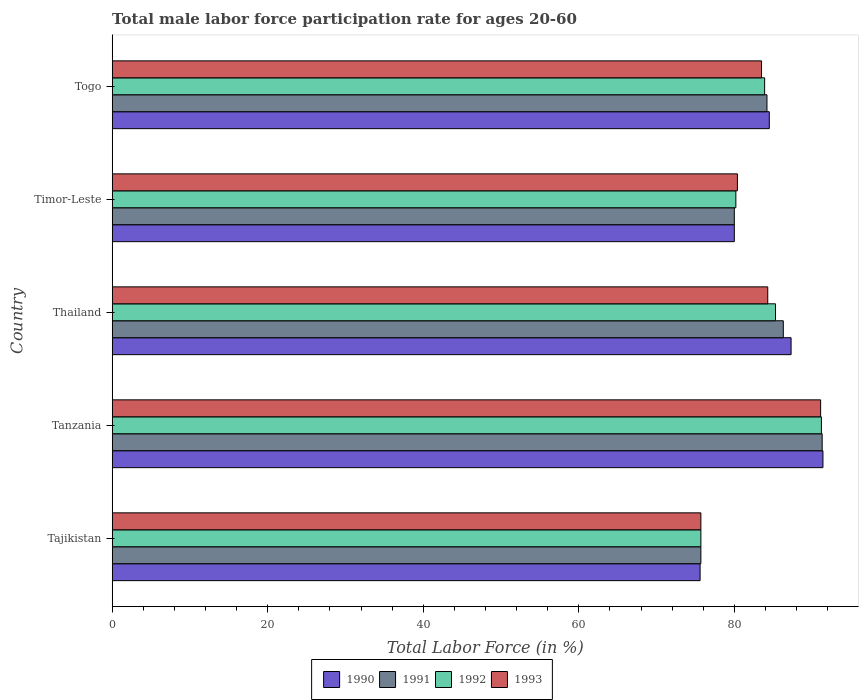How many different coloured bars are there?
Keep it short and to the point. 4. How many bars are there on the 3rd tick from the top?
Your answer should be compact. 4. What is the label of the 3rd group of bars from the top?
Your answer should be very brief. Thailand. In how many cases, is the number of bars for a given country not equal to the number of legend labels?
Offer a very short reply. 0. What is the male labor force participation rate in 1992 in Tajikistan?
Offer a terse response. 75.7. Across all countries, what is the maximum male labor force participation rate in 1993?
Ensure brevity in your answer.  91.1. Across all countries, what is the minimum male labor force participation rate in 1993?
Offer a very short reply. 75.7. In which country was the male labor force participation rate in 1990 maximum?
Make the answer very short. Tanzania. In which country was the male labor force participation rate in 1990 minimum?
Your answer should be very brief. Tajikistan. What is the total male labor force participation rate in 1990 in the graph?
Offer a terse response. 418.8. What is the difference between the male labor force participation rate in 1992 in Thailand and that in Togo?
Your answer should be very brief. 1.4. What is the difference between the male labor force participation rate in 1990 in Timor-Leste and the male labor force participation rate in 1992 in Tajikistan?
Provide a short and direct response. 4.3. What is the average male labor force participation rate in 1992 per country?
Make the answer very short. 83.26. In how many countries, is the male labor force participation rate in 1991 greater than 8 %?
Offer a terse response. 5. What is the ratio of the male labor force participation rate in 1991 in Tanzania to that in Thailand?
Provide a succinct answer. 1.06. Is the male labor force participation rate in 1990 in Tanzania less than that in Thailand?
Provide a succinct answer. No. Is the difference between the male labor force participation rate in 1991 in Tajikistan and Thailand greater than the difference between the male labor force participation rate in 1993 in Tajikistan and Thailand?
Your response must be concise. No. What is the difference between the highest and the second highest male labor force participation rate in 1991?
Your response must be concise. 5. What is the difference between the highest and the lowest male labor force participation rate in 1990?
Offer a very short reply. 15.8. Is the sum of the male labor force participation rate in 1992 in Tajikistan and Thailand greater than the maximum male labor force participation rate in 1993 across all countries?
Ensure brevity in your answer.  Yes. What does the 3rd bar from the top in Tajikistan represents?
Keep it short and to the point. 1991. What does the 3rd bar from the bottom in Tanzania represents?
Provide a succinct answer. 1992. Is it the case that in every country, the sum of the male labor force participation rate in 1993 and male labor force participation rate in 1990 is greater than the male labor force participation rate in 1992?
Provide a succinct answer. Yes. Are all the bars in the graph horizontal?
Keep it short and to the point. Yes. How many countries are there in the graph?
Provide a short and direct response. 5. Are the values on the major ticks of X-axis written in scientific E-notation?
Provide a short and direct response. No. Does the graph contain any zero values?
Ensure brevity in your answer.  No. Where does the legend appear in the graph?
Ensure brevity in your answer.  Bottom center. What is the title of the graph?
Your answer should be very brief. Total male labor force participation rate for ages 20-60. What is the Total Labor Force (in %) of 1990 in Tajikistan?
Provide a short and direct response. 75.6. What is the Total Labor Force (in %) of 1991 in Tajikistan?
Ensure brevity in your answer.  75.7. What is the Total Labor Force (in %) in 1992 in Tajikistan?
Make the answer very short. 75.7. What is the Total Labor Force (in %) of 1993 in Tajikistan?
Offer a very short reply. 75.7. What is the Total Labor Force (in %) in 1990 in Tanzania?
Make the answer very short. 91.4. What is the Total Labor Force (in %) in 1991 in Tanzania?
Provide a short and direct response. 91.3. What is the Total Labor Force (in %) in 1992 in Tanzania?
Your answer should be very brief. 91.2. What is the Total Labor Force (in %) in 1993 in Tanzania?
Provide a short and direct response. 91.1. What is the Total Labor Force (in %) of 1990 in Thailand?
Offer a very short reply. 87.3. What is the Total Labor Force (in %) in 1991 in Thailand?
Offer a very short reply. 86.3. What is the Total Labor Force (in %) of 1992 in Thailand?
Your answer should be compact. 85.3. What is the Total Labor Force (in %) in 1993 in Thailand?
Provide a short and direct response. 84.3. What is the Total Labor Force (in %) in 1990 in Timor-Leste?
Make the answer very short. 80. What is the Total Labor Force (in %) in 1992 in Timor-Leste?
Ensure brevity in your answer.  80.2. What is the Total Labor Force (in %) of 1993 in Timor-Leste?
Make the answer very short. 80.4. What is the Total Labor Force (in %) of 1990 in Togo?
Your answer should be very brief. 84.5. What is the Total Labor Force (in %) in 1991 in Togo?
Keep it short and to the point. 84.2. What is the Total Labor Force (in %) of 1992 in Togo?
Provide a succinct answer. 83.9. What is the Total Labor Force (in %) of 1993 in Togo?
Ensure brevity in your answer.  83.5. Across all countries, what is the maximum Total Labor Force (in %) of 1990?
Keep it short and to the point. 91.4. Across all countries, what is the maximum Total Labor Force (in %) of 1991?
Give a very brief answer. 91.3. Across all countries, what is the maximum Total Labor Force (in %) of 1992?
Your response must be concise. 91.2. Across all countries, what is the maximum Total Labor Force (in %) in 1993?
Your answer should be compact. 91.1. Across all countries, what is the minimum Total Labor Force (in %) in 1990?
Provide a succinct answer. 75.6. Across all countries, what is the minimum Total Labor Force (in %) in 1991?
Give a very brief answer. 75.7. Across all countries, what is the minimum Total Labor Force (in %) in 1992?
Make the answer very short. 75.7. Across all countries, what is the minimum Total Labor Force (in %) of 1993?
Offer a very short reply. 75.7. What is the total Total Labor Force (in %) in 1990 in the graph?
Provide a short and direct response. 418.8. What is the total Total Labor Force (in %) of 1991 in the graph?
Your answer should be compact. 417.5. What is the total Total Labor Force (in %) of 1992 in the graph?
Your answer should be very brief. 416.3. What is the total Total Labor Force (in %) of 1993 in the graph?
Provide a succinct answer. 415. What is the difference between the Total Labor Force (in %) of 1990 in Tajikistan and that in Tanzania?
Give a very brief answer. -15.8. What is the difference between the Total Labor Force (in %) of 1991 in Tajikistan and that in Tanzania?
Provide a succinct answer. -15.6. What is the difference between the Total Labor Force (in %) of 1992 in Tajikistan and that in Tanzania?
Provide a short and direct response. -15.5. What is the difference between the Total Labor Force (in %) in 1993 in Tajikistan and that in Tanzania?
Your answer should be very brief. -15.4. What is the difference between the Total Labor Force (in %) of 1990 in Tajikistan and that in Thailand?
Provide a short and direct response. -11.7. What is the difference between the Total Labor Force (in %) in 1993 in Tajikistan and that in Thailand?
Your answer should be compact. -8.6. What is the difference between the Total Labor Force (in %) of 1992 in Tajikistan and that in Togo?
Provide a succinct answer. -8.2. What is the difference between the Total Labor Force (in %) in 1993 in Tajikistan and that in Togo?
Offer a terse response. -7.8. What is the difference between the Total Labor Force (in %) in 1990 in Tanzania and that in Thailand?
Your answer should be very brief. 4.1. What is the difference between the Total Labor Force (in %) of 1991 in Tanzania and that in Thailand?
Give a very brief answer. 5. What is the difference between the Total Labor Force (in %) of 1993 in Tanzania and that in Thailand?
Your answer should be very brief. 6.8. What is the difference between the Total Labor Force (in %) in 1990 in Tanzania and that in Timor-Leste?
Your response must be concise. 11.4. What is the difference between the Total Labor Force (in %) in 1992 in Tanzania and that in Timor-Leste?
Provide a short and direct response. 11. What is the difference between the Total Labor Force (in %) of 1993 in Tanzania and that in Timor-Leste?
Make the answer very short. 10.7. What is the difference between the Total Labor Force (in %) of 1990 in Tanzania and that in Togo?
Keep it short and to the point. 6.9. What is the difference between the Total Labor Force (in %) in 1992 in Tanzania and that in Togo?
Give a very brief answer. 7.3. What is the difference between the Total Labor Force (in %) of 1990 in Thailand and that in Timor-Leste?
Provide a short and direct response. 7.3. What is the difference between the Total Labor Force (in %) of 1992 in Thailand and that in Timor-Leste?
Provide a short and direct response. 5.1. What is the difference between the Total Labor Force (in %) of 1993 in Thailand and that in Timor-Leste?
Ensure brevity in your answer.  3.9. What is the difference between the Total Labor Force (in %) in 1990 in Thailand and that in Togo?
Ensure brevity in your answer.  2.8. What is the difference between the Total Labor Force (in %) in 1992 in Thailand and that in Togo?
Offer a very short reply. 1.4. What is the difference between the Total Labor Force (in %) of 1993 in Thailand and that in Togo?
Provide a short and direct response. 0.8. What is the difference between the Total Labor Force (in %) of 1990 in Timor-Leste and that in Togo?
Ensure brevity in your answer.  -4.5. What is the difference between the Total Labor Force (in %) of 1991 in Timor-Leste and that in Togo?
Your response must be concise. -4.2. What is the difference between the Total Labor Force (in %) in 1993 in Timor-Leste and that in Togo?
Provide a short and direct response. -3.1. What is the difference between the Total Labor Force (in %) of 1990 in Tajikistan and the Total Labor Force (in %) of 1991 in Tanzania?
Give a very brief answer. -15.7. What is the difference between the Total Labor Force (in %) of 1990 in Tajikistan and the Total Labor Force (in %) of 1992 in Tanzania?
Keep it short and to the point. -15.6. What is the difference between the Total Labor Force (in %) of 1990 in Tajikistan and the Total Labor Force (in %) of 1993 in Tanzania?
Offer a very short reply. -15.5. What is the difference between the Total Labor Force (in %) in 1991 in Tajikistan and the Total Labor Force (in %) in 1992 in Tanzania?
Your response must be concise. -15.5. What is the difference between the Total Labor Force (in %) in 1991 in Tajikistan and the Total Labor Force (in %) in 1993 in Tanzania?
Provide a short and direct response. -15.4. What is the difference between the Total Labor Force (in %) of 1992 in Tajikistan and the Total Labor Force (in %) of 1993 in Tanzania?
Provide a short and direct response. -15.4. What is the difference between the Total Labor Force (in %) in 1990 in Tajikistan and the Total Labor Force (in %) in 1991 in Thailand?
Offer a terse response. -10.7. What is the difference between the Total Labor Force (in %) of 1990 in Tajikistan and the Total Labor Force (in %) of 1992 in Thailand?
Make the answer very short. -9.7. What is the difference between the Total Labor Force (in %) of 1992 in Tajikistan and the Total Labor Force (in %) of 1993 in Thailand?
Keep it short and to the point. -8.6. What is the difference between the Total Labor Force (in %) of 1990 in Tajikistan and the Total Labor Force (in %) of 1992 in Timor-Leste?
Offer a terse response. -4.6. What is the difference between the Total Labor Force (in %) of 1990 in Tajikistan and the Total Labor Force (in %) of 1993 in Timor-Leste?
Offer a terse response. -4.8. What is the difference between the Total Labor Force (in %) in 1991 in Tajikistan and the Total Labor Force (in %) in 1992 in Timor-Leste?
Provide a short and direct response. -4.5. What is the difference between the Total Labor Force (in %) of 1990 in Tajikistan and the Total Labor Force (in %) of 1991 in Togo?
Your answer should be very brief. -8.6. What is the difference between the Total Labor Force (in %) of 1990 in Tajikistan and the Total Labor Force (in %) of 1992 in Togo?
Offer a very short reply. -8.3. What is the difference between the Total Labor Force (in %) in 1990 in Tajikistan and the Total Labor Force (in %) in 1993 in Togo?
Your answer should be compact. -7.9. What is the difference between the Total Labor Force (in %) in 1991 in Tajikistan and the Total Labor Force (in %) in 1992 in Togo?
Offer a terse response. -8.2. What is the difference between the Total Labor Force (in %) in 1992 in Tajikistan and the Total Labor Force (in %) in 1993 in Togo?
Your response must be concise. -7.8. What is the difference between the Total Labor Force (in %) in 1990 in Tanzania and the Total Labor Force (in %) in 1992 in Thailand?
Offer a terse response. 6.1. What is the difference between the Total Labor Force (in %) in 1990 in Tanzania and the Total Labor Force (in %) in 1993 in Thailand?
Your response must be concise. 7.1. What is the difference between the Total Labor Force (in %) of 1991 in Tanzania and the Total Labor Force (in %) of 1992 in Thailand?
Offer a very short reply. 6. What is the difference between the Total Labor Force (in %) of 1991 in Tanzania and the Total Labor Force (in %) of 1993 in Thailand?
Your answer should be compact. 7. What is the difference between the Total Labor Force (in %) in 1990 in Tanzania and the Total Labor Force (in %) in 1991 in Timor-Leste?
Make the answer very short. 11.4. What is the difference between the Total Labor Force (in %) of 1990 in Tanzania and the Total Labor Force (in %) of 1993 in Timor-Leste?
Keep it short and to the point. 11. What is the difference between the Total Labor Force (in %) in 1991 in Tanzania and the Total Labor Force (in %) in 1992 in Timor-Leste?
Offer a terse response. 11.1. What is the difference between the Total Labor Force (in %) in 1991 in Tanzania and the Total Labor Force (in %) in 1993 in Timor-Leste?
Keep it short and to the point. 10.9. What is the difference between the Total Labor Force (in %) in 1990 in Tanzania and the Total Labor Force (in %) in 1992 in Togo?
Provide a short and direct response. 7.5. What is the difference between the Total Labor Force (in %) of 1991 in Tanzania and the Total Labor Force (in %) of 1993 in Togo?
Your answer should be very brief. 7.8. What is the difference between the Total Labor Force (in %) in 1990 in Thailand and the Total Labor Force (in %) in 1992 in Timor-Leste?
Make the answer very short. 7.1. What is the difference between the Total Labor Force (in %) of 1992 in Thailand and the Total Labor Force (in %) of 1993 in Timor-Leste?
Ensure brevity in your answer.  4.9. What is the difference between the Total Labor Force (in %) in 1990 in Thailand and the Total Labor Force (in %) in 1991 in Togo?
Ensure brevity in your answer.  3.1. What is the difference between the Total Labor Force (in %) in 1990 in Thailand and the Total Labor Force (in %) in 1993 in Togo?
Provide a short and direct response. 3.8. What is the difference between the Total Labor Force (in %) in 1991 in Thailand and the Total Labor Force (in %) in 1992 in Togo?
Keep it short and to the point. 2.4. What is the difference between the Total Labor Force (in %) in 1991 in Thailand and the Total Labor Force (in %) in 1993 in Togo?
Your answer should be very brief. 2.8. What is the difference between the Total Labor Force (in %) of 1990 in Timor-Leste and the Total Labor Force (in %) of 1992 in Togo?
Your response must be concise. -3.9. What is the difference between the Total Labor Force (in %) in 1990 in Timor-Leste and the Total Labor Force (in %) in 1993 in Togo?
Make the answer very short. -3.5. What is the difference between the Total Labor Force (in %) in 1991 in Timor-Leste and the Total Labor Force (in %) in 1993 in Togo?
Make the answer very short. -3.5. What is the difference between the Total Labor Force (in %) of 1992 in Timor-Leste and the Total Labor Force (in %) of 1993 in Togo?
Your answer should be very brief. -3.3. What is the average Total Labor Force (in %) in 1990 per country?
Provide a succinct answer. 83.76. What is the average Total Labor Force (in %) in 1991 per country?
Your response must be concise. 83.5. What is the average Total Labor Force (in %) in 1992 per country?
Ensure brevity in your answer.  83.26. What is the average Total Labor Force (in %) of 1993 per country?
Offer a very short reply. 83. What is the difference between the Total Labor Force (in %) in 1990 and Total Labor Force (in %) in 1991 in Tajikistan?
Your answer should be compact. -0.1. What is the difference between the Total Labor Force (in %) in 1990 and Total Labor Force (in %) in 1993 in Tajikistan?
Offer a terse response. -0.1. What is the difference between the Total Labor Force (in %) in 1991 and Total Labor Force (in %) in 1993 in Tajikistan?
Make the answer very short. 0. What is the difference between the Total Labor Force (in %) in 1992 and Total Labor Force (in %) in 1993 in Tajikistan?
Your answer should be compact. 0. What is the difference between the Total Labor Force (in %) of 1990 and Total Labor Force (in %) of 1991 in Tanzania?
Make the answer very short. 0.1. What is the difference between the Total Labor Force (in %) in 1990 and Total Labor Force (in %) in 1993 in Tanzania?
Your response must be concise. 0.3. What is the difference between the Total Labor Force (in %) in 1991 and Total Labor Force (in %) in 1992 in Tanzania?
Your answer should be very brief. 0.1. What is the difference between the Total Labor Force (in %) of 1990 and Total Labor Force (in %) of 1991 in Thailand?
Keep it short and to the point. 1. What is the difference between the Total Labor Force (in %) in 1990 and Total Labor Force (in %) in 1993 in Thailand?
Keep it short and to the point. 3. What is the difference between the Total Labor Force (in %) of 1991 and Total Labor Force (in %) of 1992 in Thailand?
Give a very brief answer. 1. What is the difference between the Total Labor Force (in %) of 1990 and Total Labor Force (in %) of 1992 in Timor-Leste?
Your response must be concise. -0.2. What is the difference between the Total Labor Force (in %) in 1990 and Total Labor Force (in %) in 1993 in Timor-Leste?
Give a very brief answer. -0.4. What is the difference between the Total Labor Force (in %) in 1990 and Total Labor Force (in %) in 1991 in Togo?
Provide a short and direct response. 0.3. What is the difference between the Total Labor Force (in %) of 1990 and Total Labor Force (in %) of 1993 in Togo?
Ensure brevity in your answer.  1. What is the difference between the Total Labor Force (in %) in 1991 and Total Labor Force (in %) in 1993 in Togo?
Offer a very short reply. 0.7. What is the difference between the Total Labor Force (in %) in 1992 and Total Labor Force (in %) in 1993 in Togo?
Keep it short and to the point. 0.4. What is the ratio of the Total Labor Force (in %) in 1990 in Tajikistan to that in Tanzania?
Ensure brevity in your answer.  0.83. What is the ratio of the Total Labor Force (in %) in 1991 in Tajikistan to that in Tanzania?
Your answer should be very brief. 0.83. What is the ratio of the Total Labor Force (in %) in 1992 in Tajikistan to that in Tanzania?
Your response must be concise. 0.83. What is the ratio of the Total Labor Force (in %) in 1993 in Tajikistan to that in Tanzania?
Provide a short and direct response. 0.83. What is the ratio of the Total Labor Force (in %) in 1990 in Tajikistan to that in Thailand?
Your answer should be compact. 0.87. What is the ratio of the Total Labor Force (in %) in 1991 in Tajikistan to that in Thailand?
Your answer should be very brief. 0.88. What is the ratio of the Total Labor Force (in %) of 1992 in Tajikistan to that in Thailand?
Provide a short and direct response. 0.89. What is the ratio of the Total Labor Force (in %) of 1993 in Tajikistan to that in Thailand?
Your response must be concise. 0.9. What is the ratio of the Total Labor Force (in %) of 1990 in Tajikistan to that in Timor-Leste?
Provide a succinct answer. 0.94. What is the ratio of the Total Labor Force (in %) of 1991 in Tajikistan to that in Timor-Leste?
Your answer should be compact. 0.95. What is the ratio of the Total Labor Force (in %) in 1992 in Tajikistan to that in Timor-Leste?
Offer a very short reply. 0.94. What is the ratio of the Total Labor Force (in %) in 1993 in Tajikistan to that in Timor-Leste?
Your response must be concise. 0.94. What is the ratio of the Total Labor Force (in %) of 1990 in Tajikistan to that in Togo?
Your response must be concise. 0.89. What is the ratio of the Total Labor Force (in %) in 1991 in Tajikistan to that in Togo?
Give a very brief answer. 0.9. What is the ratio of the Total Labor Force (in %) of 1992 in Tajikistan to that in Togo?
Give a very brief answer. 0.9. What is the ratio of the Total Labor Force (in %) in 1993 in Tajikistan to that in Togo?
Give a very brief answer. 0.91. What is the ratio of the Total Labor Force (in %) of 1990 in Tanzania to that in Thailand?
Give a very brief answer. 1.05. What is the ratio of the Total Labor Force (in %) of 1991 in Tanzania to that in Thailand?
Ensure brevity in your answer.  1.06. What is the ratio of the Total Labor Force (in %) in 1992 in Tanzania to that in Thailand?
Ensure brevity in your answer.  1.07. What is the ratio of the Total Labor Force (in %) in 1993 in Tanzania to that in Thailand?
Provide a succinct answer. 1.08. What is the ratio of the Total Labor Force (in %) in 1990 in Tanzania to that in Timor-Leste?
Your answer should be compact. 1.14. What is the ratio of the Total Labor Force (in %) in 1991 in Tanzania to that in Timor-Leste?
Offer a terse response. 1.14. What is the ratio of the Total Labor Force (in %) of 1992 in Tanzania to that in Timor-Leste?
Offer a terse response. 1.14. What is the ratio of the Total Labor Force (in %) in 1993 in Tanzania to that in Timor-Leste?
Make the answer very short. 1.13. What is the ratio of the Total Labor Force (in %) of 1990 in Tanzania to that in Togo?
Provide a short and direct response. 1.08. What is the ratio of the Total Labor Force (in %) of 1991 in Tanzania to that in Togo?
Make the answer very short. 1.08. What is the ratio of the Total Labor Force (in %) of 1992 in Tanzania to that in Togo?
Ensure brevity in your answer.  1.09. What is the ratio of the Total Labor Force (in %) of 1993 in Tanzania to that in Togo?
Keep it short and to the point. 1.09. What is the ratio of the Total Labor Force (in %) in 1990 in Thailand to that in Timor-Leste?
Provide a short and direct response. 1.09. What is the ratio of the Total Labor Force (in %) of 1991 in Thailand to that in Timor-Leste?
Ensure brevity in your answer.  1.08. What is the ratio of the Total Labor Force (in %) in 1992 in Thailand to that in Timor-Leste?
Ensure brevity in your answer.  1.06. What is the ratio of the Total Labor Force (in %) of 1993 in Thailand to that in Timor-Leste?
Ensure brevity in your answer.  1.05. What is the ratio of the Total Labor Force (in %) in 1990 in Thailand to that in Togo?
Offer a very short reply. 1.03. What is the ratio of the Total Labor Force (in %) in 1991 in Thailand to that in Togo?
Give a very brief answer. 1.02. What is the ratio of the Total Labor Force (in %) in 1992 in Thailand to that in Togo?
Ensure brevity in your answer.  1.02. What is the ratio of the Total Labor Force (in %) of 1993 in Thailand to that in Togo?
Provide a succinct answer. 1.01. What is the ratio of the Total Labor Force (in %) in 1990 in Timor-Leste to that in Togo?
Provide a succinct answer. 0.95. What is the ratio of the Total Labor Force (in %) in 1991 in Timor-Leste to that in Togo?
Make the answer very short. 0.95. What is the ratio of the Total Labor Force (in %) in 1992 in Timor-Leste to that in Togo?
Give a very brief answer. 0.96. What is the ratio of the Total Labor Force (in %) of 1993 in Timor-Leste to that in Togo?
Offer a very short reply. 0.96. What is the difference between the highest and the lowest Total Labor Force (in %) in 1991?
Give a very brief answer. 15.6. What is the difference between the highest and the lowest Total Labor Force (in %) of 1993?
Provide a succinct answer. 15.4. 